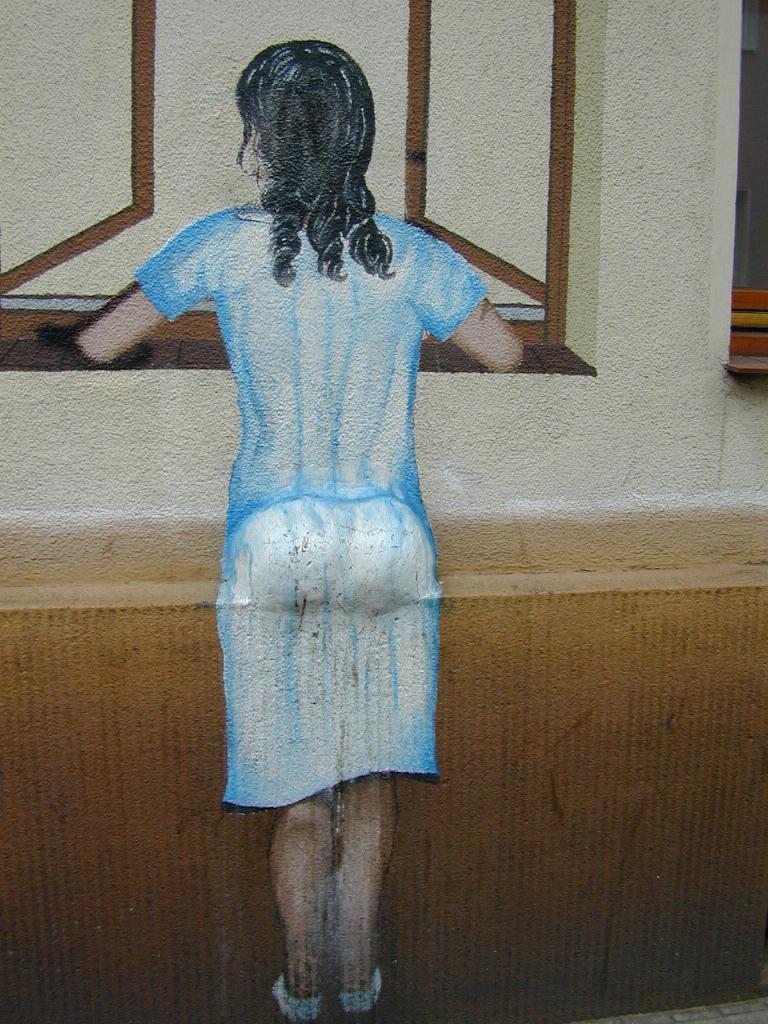In one or two sentences, can you explain what this image depicts? In the center of the image there is a painting of a girl. There is a window. 